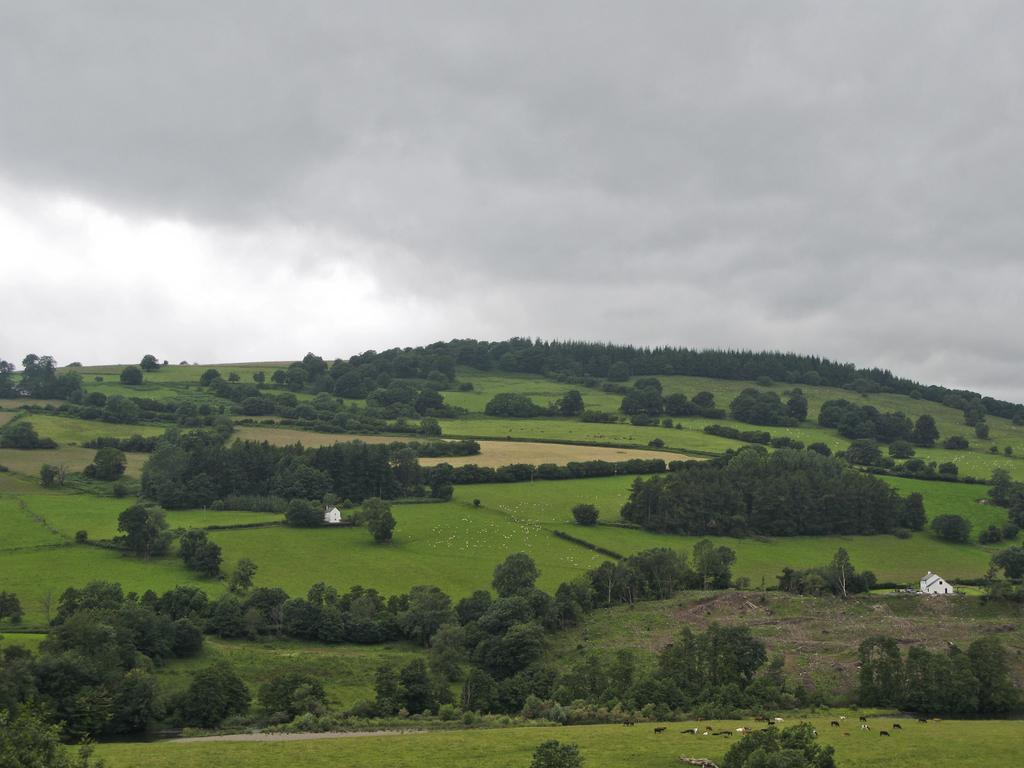What type of vegetation can be seen in the image? There is grass in the image. Are there any other natural elements present in the image? Yes, there are trees in the image. What type of structures can be seen in the image? There are houses in the image. What is visible in the background of the image? The sky is visible in the background of the image. What can be observed in the sky? Clouds are present in the sky. Can you describe the orange wave in the image? There is no orange wave present in the image. How many trains can be seen in the image? There are no trains visible in the image. 